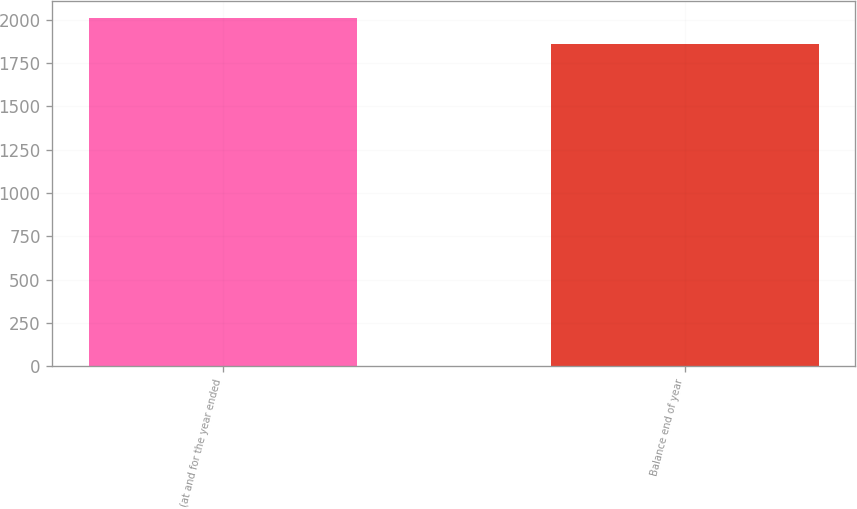<chart> <loc_0><loc_0><loc_500><loc_500><bar_chart><fcel>(at and for the year ended<fcel>Balance end of year<nl><fcel>2010<fcel>1859<nl></chart> 